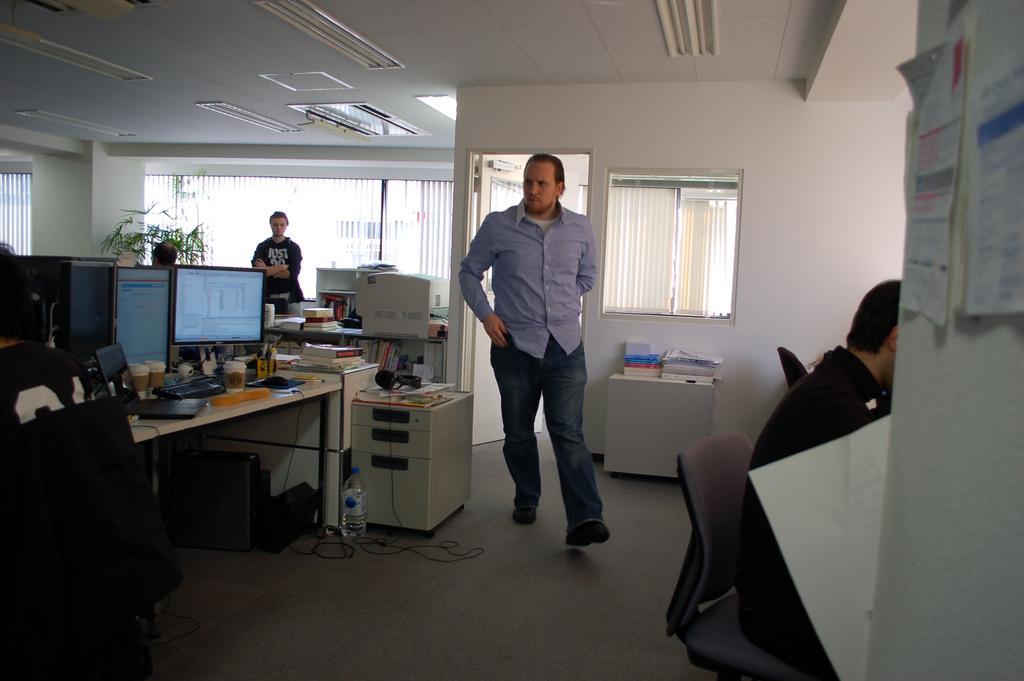Describe this image in one or two sentences. In this image, There is a floor which is in gray color, There are some tables in white color on that table there are some computers, In the middle there is a man walking, In the right side there is a person sitting on the chair, In the background there is a wall in white color on that wall there is a window, In the top there is a white color roof and there are some lights on the roof. 